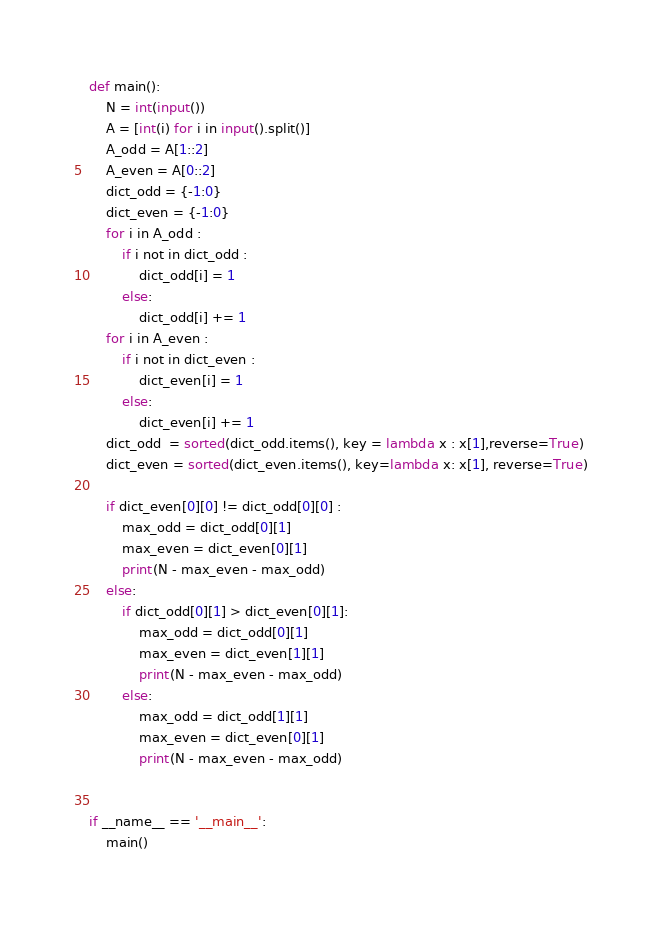<code> <loc_0><loc_0><loc_500><loc_500><_Python_>def main():
    N = int(input())
    A = [int(i) for i in input().split()]
    A_odd = A[1::2]
    A_even = A[0::2]
    dict_odd = {-1:0}
    dict_even = {-1:0}
    for i in A_odd :
        if i not in dict_odd :
            dict_odd[i] = 1
        else:
            dict_odd[i] += 1
    for i in A_even :
        if i not in dict_even :
            dict_even[i] = 1
        else:
            dict_even[i] += 1
    dict_odd  = sorted(dict_odd.items(), key = lambda x : x[1],reverse=True)
    dict_even = sorted(dict_even.items(), key=lambda x: x[1], reverse=True)

    if dict_even[0][0] != dict_odd[0][0] :
        max_odd = dict_odd[0][1]
        max_even = dict_even[0][1]
        print(N - max_even - max_odd)
    else:
        if dict_odd[0][1] > dict_even[0][1]:
            max_odd = dict_odd[0][1]
            max_even = dict_even[1][1]
            print(N - max_even - max_odd)
        else:
            max_odd = dict_odd[1][1]
            max_even = dict_even[0][1]
            print(N - max_even - max_odd)


if __name__ == '__main__':
    main()</code> 